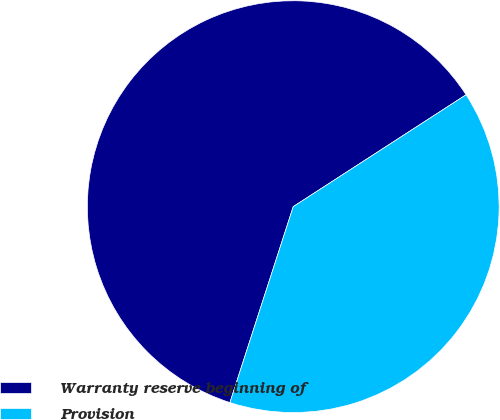Convert chart. <chart><loc_0><loc_0><loc_500><loc_500><pie_chart><fcel>Warranty reserve beginning of<fcel>Provision<nl><fcel>60.88%<fcel>39.12%<nl></chart> 